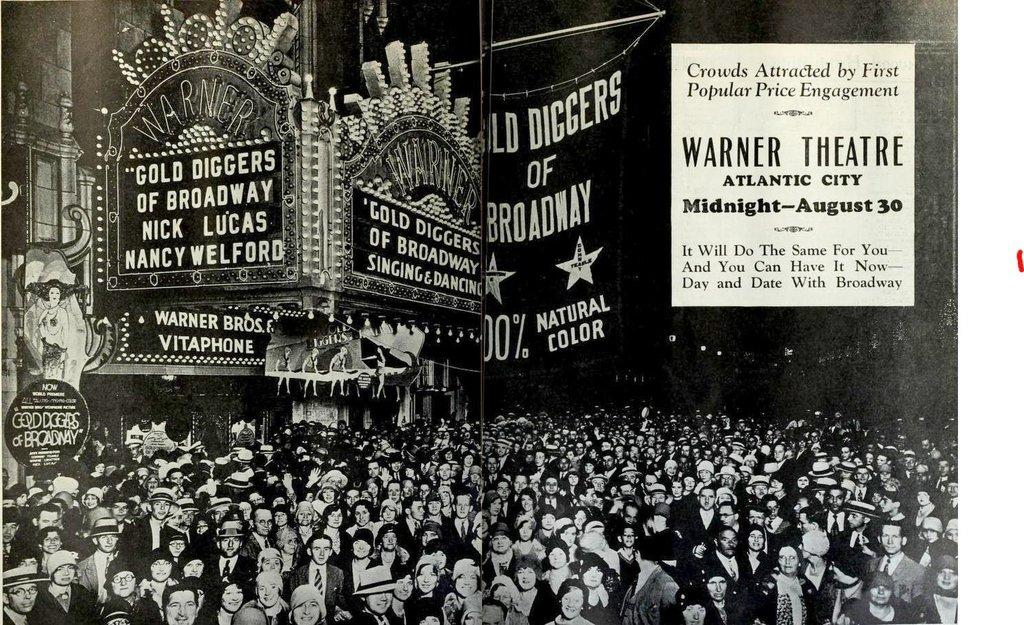<image>
Summarize the visual content of the image. An old time photograph shows a vintage New York theater presenting "Gold Diggers of Broadway". 